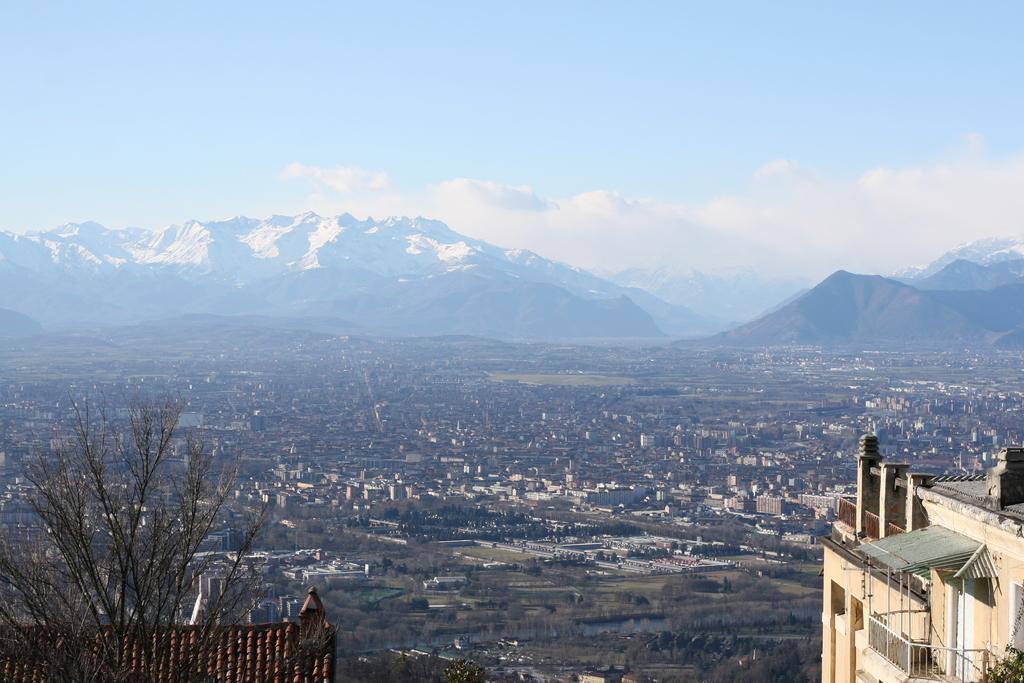In one or two sentences, can you explain what this image depicts? Left bottom of the image we can see dried tree and roof top. Here we can see buildings. Background we can see hills and sky with clouds. 